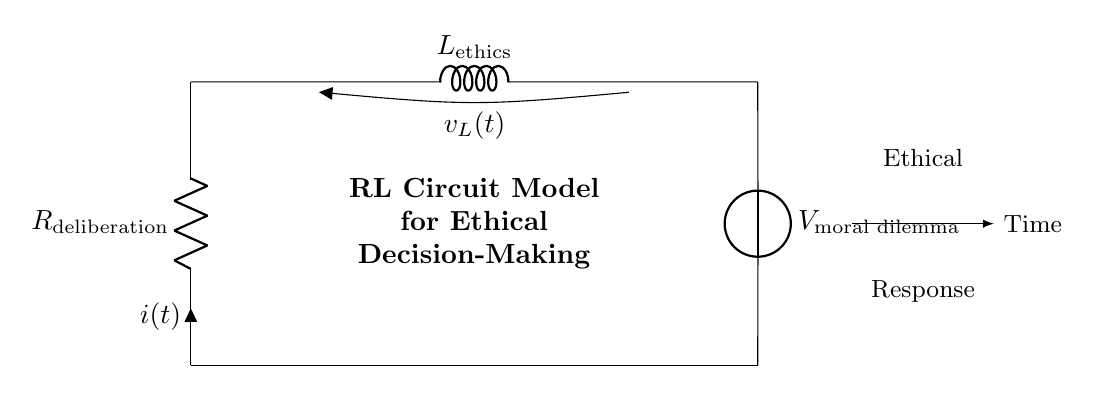What does the resistor represent in this circuit? The resistor represents the deliberation process, indicating how resistance in decision-making can affect the overall response over time.
Answer: R_deliberation What does the inductor symbolize in this circuit? The inductor symbolizes the ethical considerations that take time to develop and respond to, reflecting the gradual build-up of ethical understanding during decision-making.
Answer: L_ethics What is the voltage source labeled in the circuit? The voltage source labeled in the circuit represents the moral dilemma that provides the initial potential for the decision-making process.
Answer: V_moral dilemma How is the current represented in this circuit? The current is represented by the symbol i(t) and shows the flow of ethical response resulting from the deliberation process over time.
Answer: i(t) What does a higher resistance in the circuit indicate about ethical decision-making? A higher resistance in this context would indicate a longer deliberation time, suggesting more thorough consideration before arriving at an ethical response.
Answer: Longer deliberation How does the inductance affect the ethical decision-making process? The inductance impacts the speed at which the ethical response builds up; a higher inductance means a slower response time as ethical considerations take longer to manifest.
Answer: Slower response What is the overall type of this circuit? This circuit is an RL circuit, which consists of a resistor and an inductor in series, modeling the dynamic nature of ethical decision-making.
Answer: RL circuit 